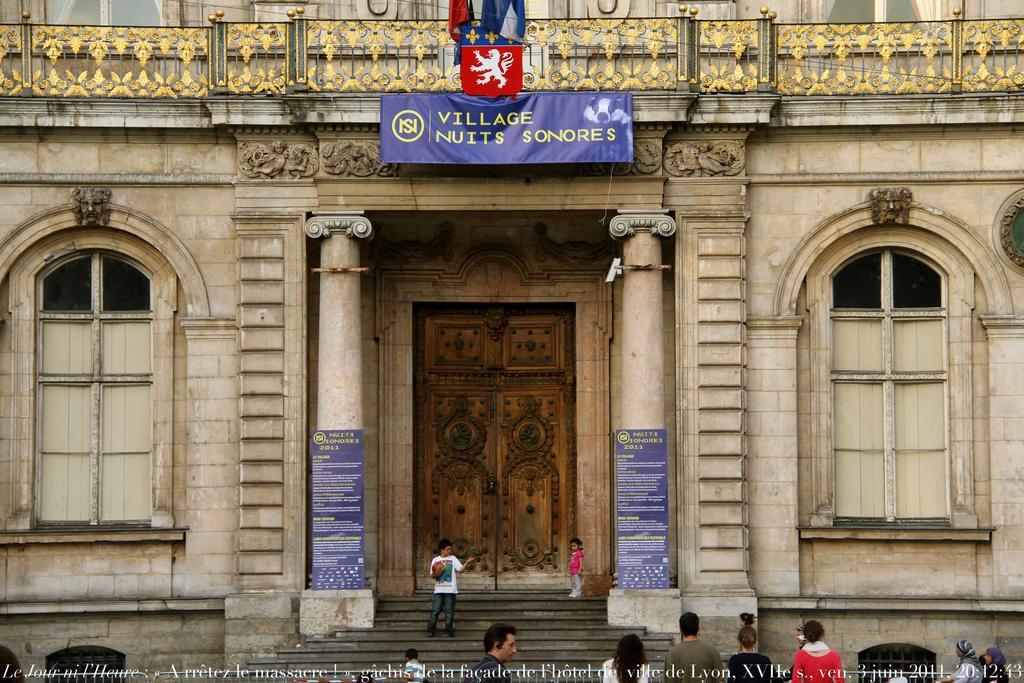How would you summarize this image in a sentence or two? In this image in the center there is one building at the bottom there are some stairs and some people are walking, and on the top of the image there is one board. On the right side and left side there are two windows. 